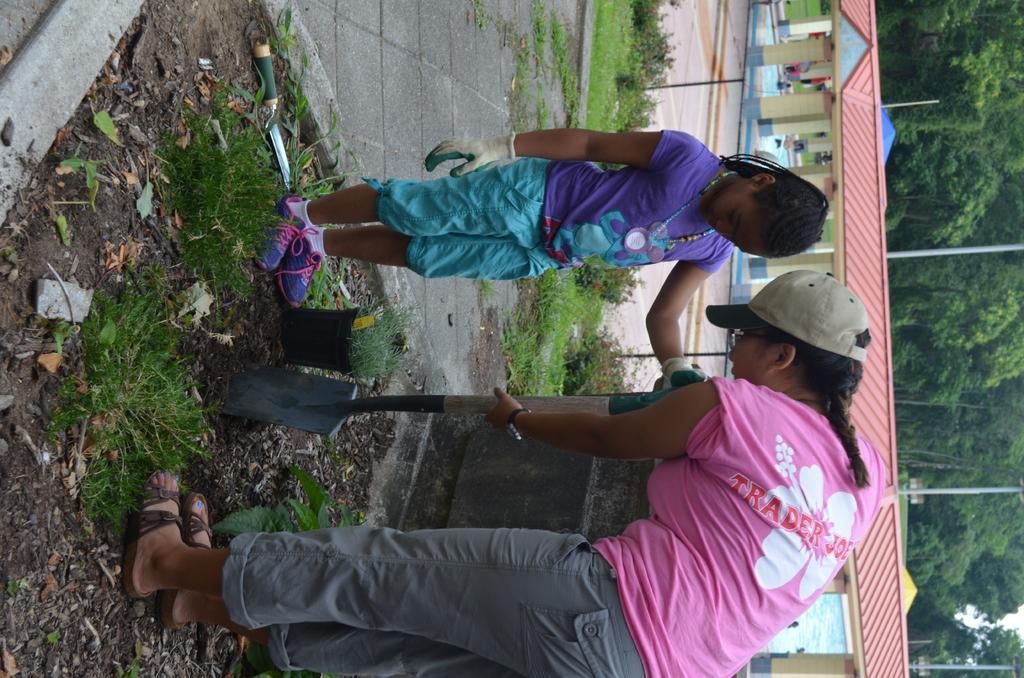In one or two sentences, can you explain what this image depicts? In the center of the picture there is a woman and a girl standing in a garden. In the foreground there are shrubs, leaves and soil. On the right, there are houses, trees and poles. In the center of the picture there are shrubs, flowers and grass. 